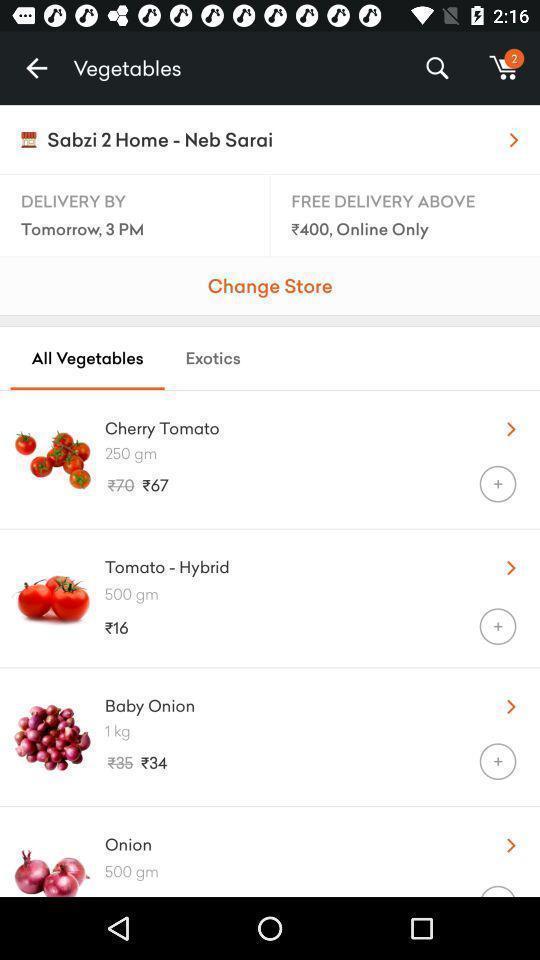What is the overall content of this screenshot? Screen shows list of vegetables in a shopping app. 